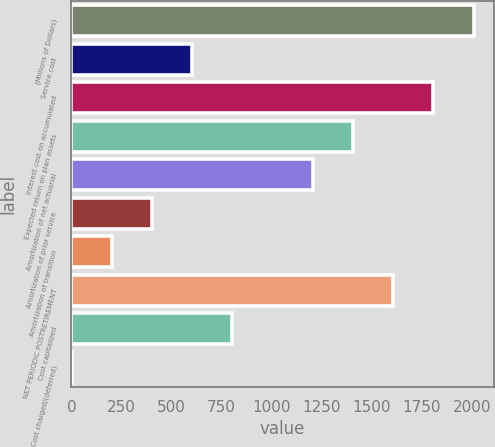Convert chart. <chart><loc_0><loc_0><loc_500><loc_500><bar_chart><fcel>(Millions of Dollars)<fcel>Service cost<fcel>Interest cost on accumulated<fcel>Expected return on plan assets<fcel>Amortization of net actuarial<fcel>Amortization of prior service<fcel>Amortization of transition<fcel>NET PERIODIC POSTRETIREMENT<fcel>Cost capitalized<fcel>Cost charged/(deferred)<nl><fcel>2009<fcel>603.4<fcel>1808.2<fcel>1406.6<fcel>1205.8<fcel>402.6<fcel>201.8<fcel>1607.4<fcel>804.2<fcel>1<nl></chart> 